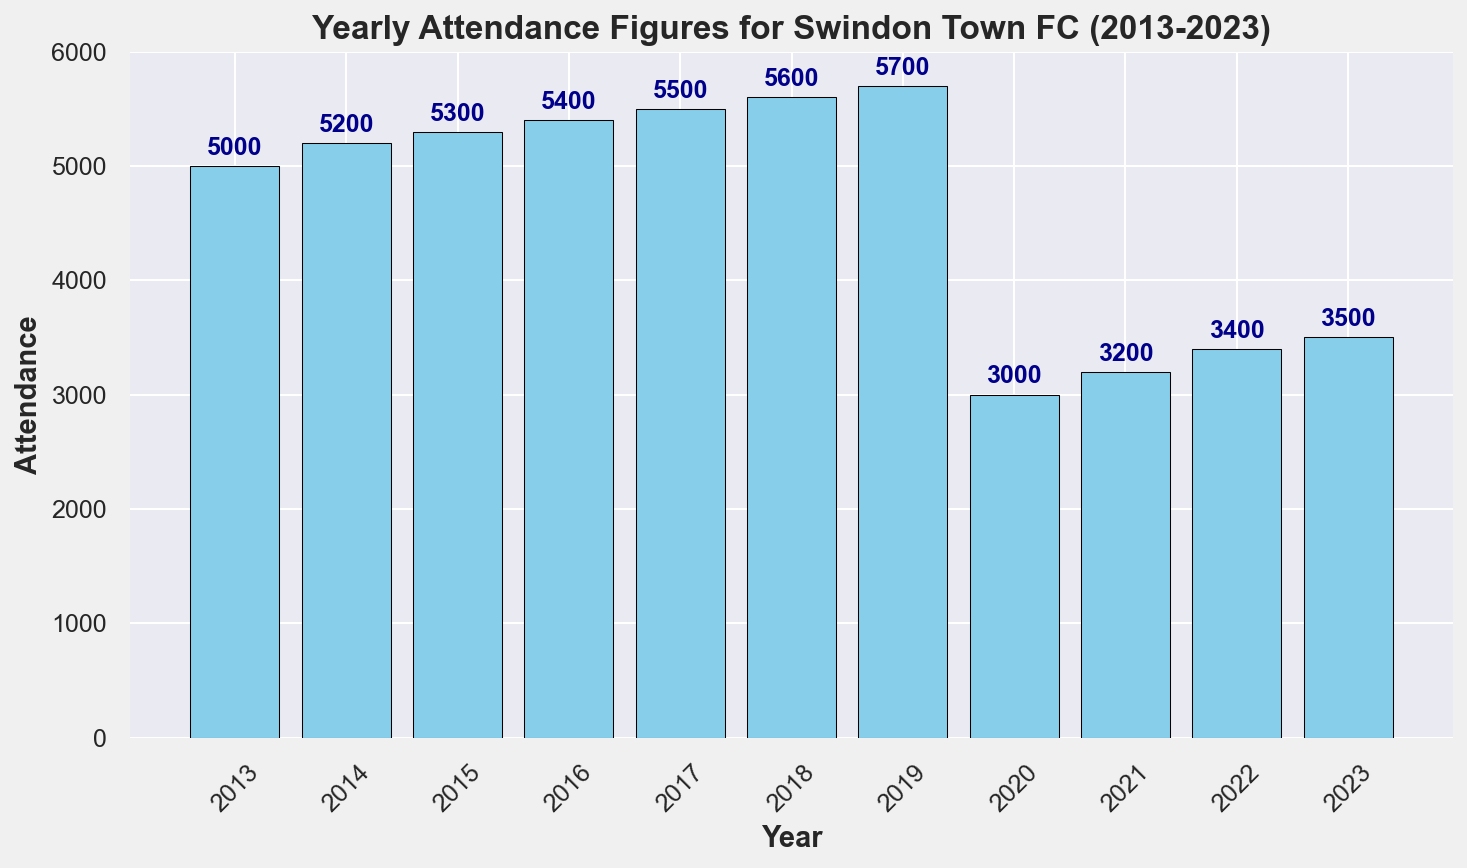What's the attendance in 2020? Look at the bar corresponding to the year 2020. The height of the bar and the annotation on top indicate the attendance figure.
Answer: 3000 In which year did Swindon Town FC have the highest attendance? Compare the heights of all bars. The bar for 2019 is the tallest, indicating the highest attendance.
Answer: 2019 How did the attendance change from 2019 to 2020? Check the heights of the bars for 2019 and 2020. The height drops from 5700 in 2019 to 3000 in 2020, indicating a decrease.
Answer: Decreased What is the average attendance between 2013 and 2019? Sum the attendance values from 2013 to 2019 and divide by the number of years (7). (5000 + 5200 + 5300 + 5400 + 5500 + 5600 + 5700) / 7 = 37700 / 7 = 5385.71
Answer: 5386 What is the difference in attendance between 2018 and 2023? Subtract the attendance in 2023 from the attendance in 2018. 5600 - 3500 = 2100
Answer: 2100 Did the attendance increase or decrease from 2021 to 2022? Compare the height of the bars for 2021 and 2022. The bar for 2022 is slightly taller than 2021, indicating an increase.
Answer: Increased What is the median attendance over the entire period? List the attendance values in ascending order: (3000, 3200, 3400, 3500, 5000, 5200, 5300, 5400, 5500, 5600, 5700). The median is the middle value, which is 5200.
Answer: 5200 Between which years did Swindon Town FC see the largest decrease in attendance? Compare the drops in attendance between consecutive years. The largest decrease is from 2019 to 2020, where the attendance drops from 5700 to 3000.
Answer: 2019 to 2020 What is the cumulative attendance from 2013 to 2016? Sum the attendance values from 2013 to 2016. 5000 + 5200 + 5300 + 5400 = 20900
Answer: 20900 Which year had an attendance closest to 4000? Look at the heights of the bars and find the year with attendance closest to 4000. The bar for 2023 with an attendance of 3500 is the closest.
Answer: 2023 